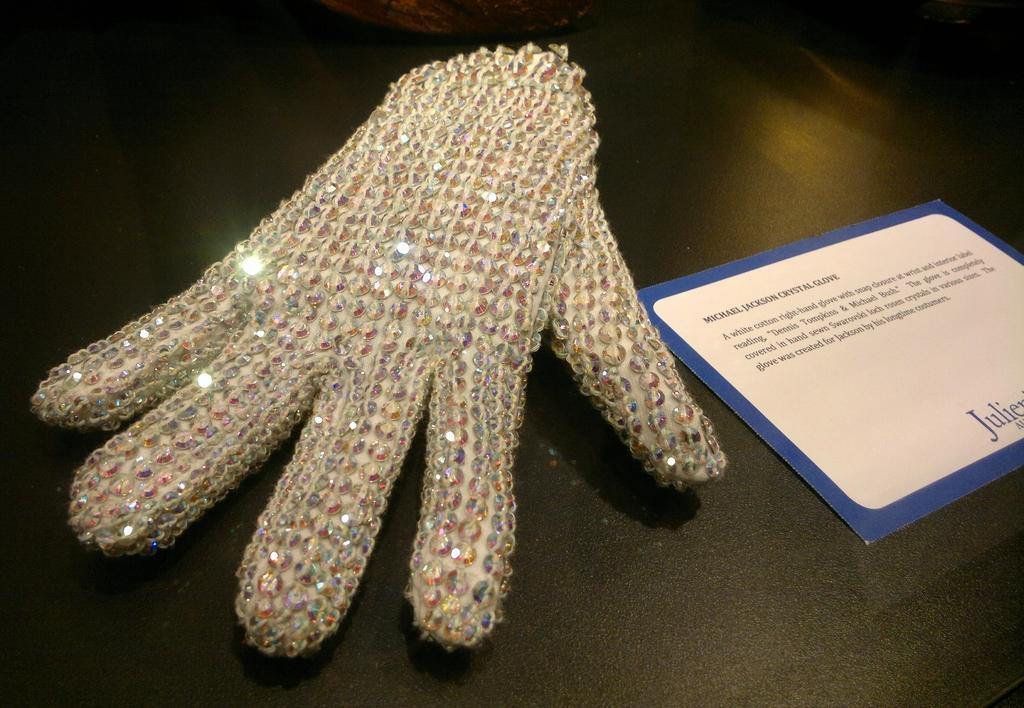Could you give a brief overview of what you see in this image? In this image we can see a card with some text on it and a glove which are placed on the surface. 